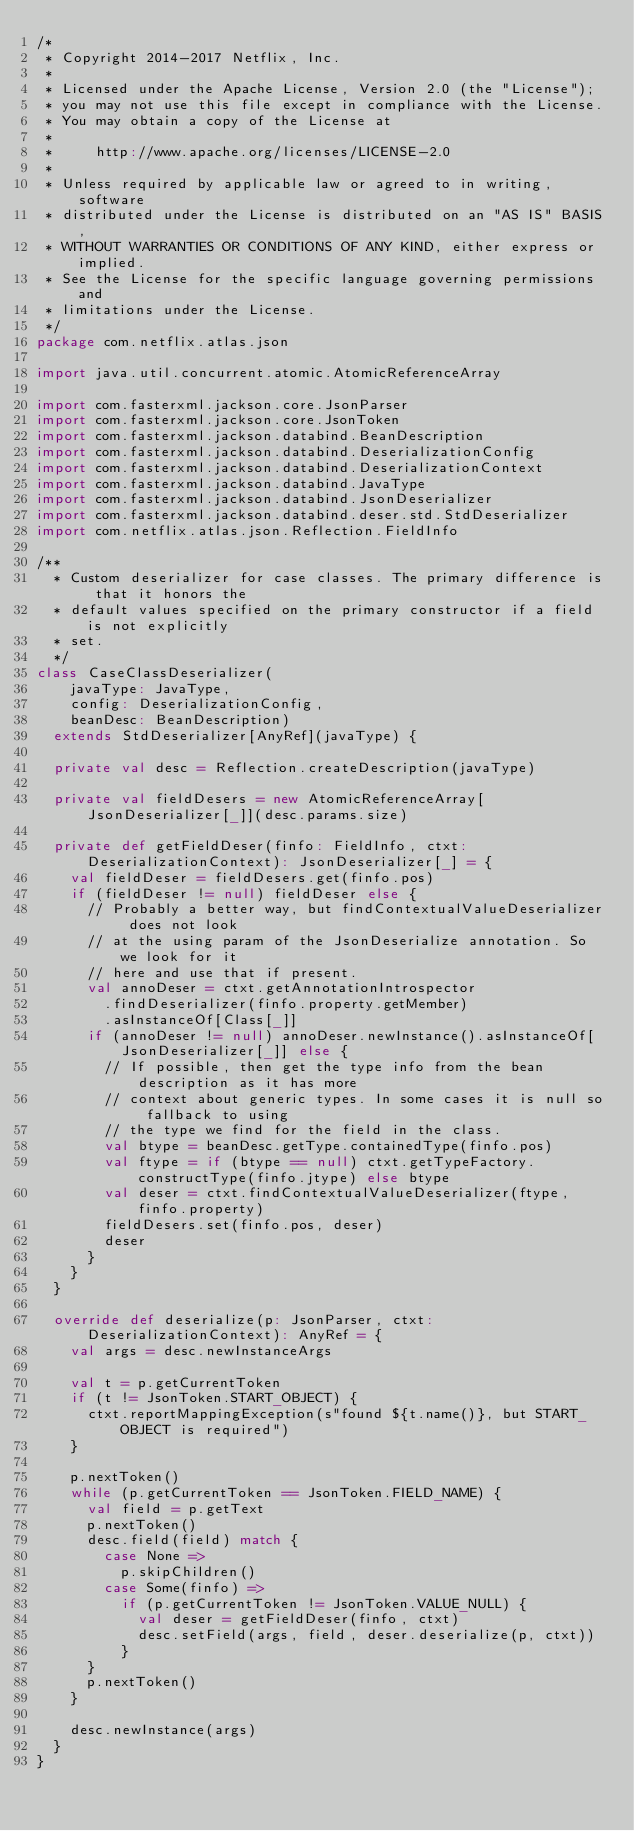<code> <loc_0><loc_0><loc_500><loc_500><_Scala_>/*
 * Copyright 2014-2017 Netflix, Inc.
 *
 * Licensed under the Apache License, Version 2.0 (the "License");
 * you may not use this file except in compliance with the License.
 * You may obtain a copy of the License at
 *
 *     http://www.apache.org/licenses/LICENSE-2.0
 *
 * Unless required by applicable law or agreed to in writing, software
 * distributed under the License is distributed on an "AS IS" BASIS,
 * WITHOUT WARRANTIES OR CONDITIONS OF ANY KIND, either express or implied.
 * See the License for the specific language governing permissions and
 * limitations under the License.
 */
package com.netflix.atlas.json

import java.util.concurrent.atomic.AtomicReferenceArray

import com.fasterxml.jackson.core.JsonParser
import com.fasterxml.jackson.core.JsonToken
import com.fasterxml.jackson.databind.BeanDescription
import com.fasterxml.jackson.databind.DeserializationConfig
import com.fasterxml.jackson.databind.DeserializationContext
import com.fasterxml.jackson.databind.JavaType
import com.fasterxml.jackson.databind.JsonDeserializer
import com.fasterxml.jackson.databind.deser.std.StdDeserializer
import com.netflix.atlas.json.Reflection.FieldInfo

/**
  * Custom deserializer for case classes. The primary difference is that it honors the
  * default values specified on the primary constructor if a field is not explicitly
  * set.
  */
class CaseClassDeserializer(
    javaType: JavaType,
    config: DeserializationConfig,
    beanDesc: BeanDescription)
  extends StdDeserializer[AnyRef](javaType) {

  private val desc = Reflection.createDescription(javaType)

  private val fieldDesers = new AtomicReferenceArray[JsonDeserializer[_]](desc.params.size)

  private def getFieldDeser(finfo: FieldInfo, ctxt: DeserializationContext): JsonDeserializer[_] = {
    val fieldDeser = fieldDesers.get(finfo.pos)
    if (fieldDeser != null) fieldDeser else {
      // Probably a better way, but findContextualValueDeserializer does not look
      // at the using param of the JsonDeserialize annotation. So we look for it
      // here and use that if present.
      val annoDeser = ctxt.getAnnotationIntrospector
        .findDeserializer(finfo.property.getMember)
        .asInstanceOf[Class[_]]
      if (annoDeser != null) annoDeser.newInstance().asInstanceOf[JsonDeserializer[_]] else {
        // If possible, then get the type info from the bean description as it has more
        // context about generic types. In some cases it is null so fallback to using
        // the type we find for the field in the class.
        val btype = beanDesc.getType.containedType(finfo.pos)
        val ftype = if (btype == null) ctxt.getTypeFactory.constructType(finfo.jtype) else btype
        val deser = ctxt.findContextualValueDeserializer(ftype, finfo.property)
        fieldDesers.set(finfo.pos, deser)
        deser
      }
    }
  }

  override def deserialize(p: JsonParser, ctxt: DeserializationContext): AnyRef = {
    val args = desc.newInstanceArgs

    val t = p.getCurrentToken
    if (t != JsonToken.START_OBJECT) {
      ctxt.reportMappingException(s"found ${t.name()}, but START_OBJECT is required")
    }

    p.nextToken()
    while (p.getCurrentToken == JsonToken.FIELD_NAME) {
      val field = p.getText
      p.nextToken()
      desc.field(field) match {
        case None =>
          p.skipChildren()
        case Some(finfo) =>
          if (p.getCurrentToken != JsonToken.VALUE_NULL) {
            val deser = getFieldDeser(finfo, ctxt)
            desc.setField(args, field, deser.deserialize(p, ctxt))
          }
      }
      p.nextToken()
    }

    desc.newInstance(args)
  }
}
</code> 